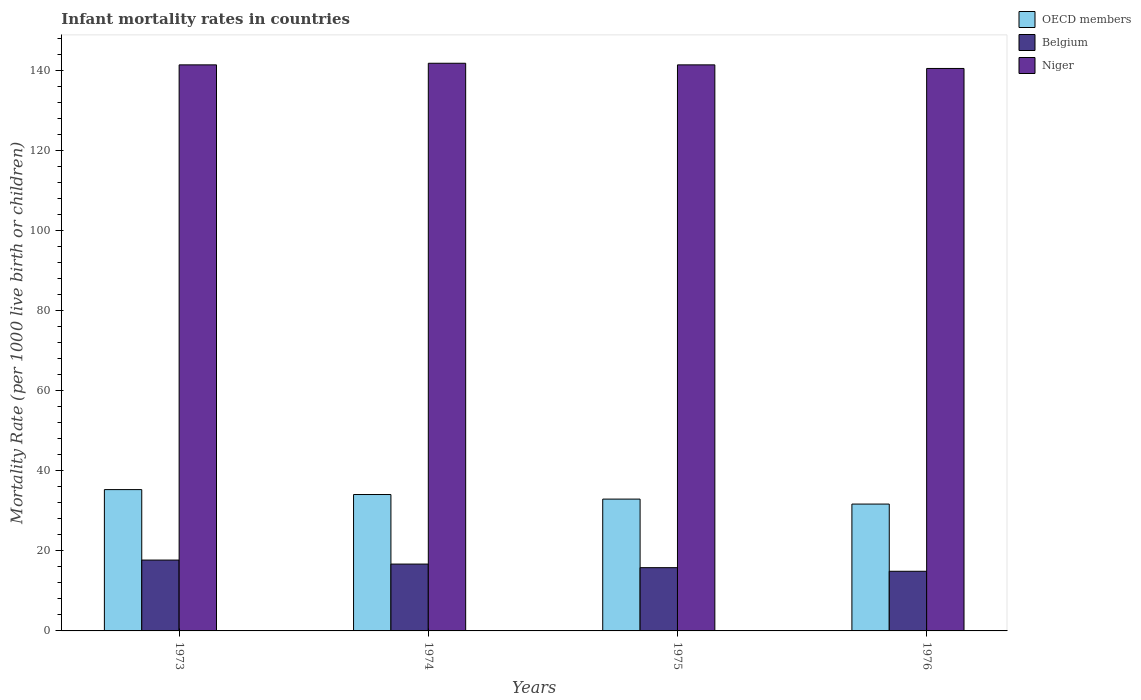Are the number of bars per tick equal to the number of legend labels?
Keep it short and to the point. Yes. Are the number of bars on each tick of the X-axis equal?
Offer a terse response. Yes. How many bars are there on the 4th tick from the right?
Offer a very short reply. 3. What is the label of the 3rd group of bars from the left?
Give a very brief answer. 1975. In how many cases, is the number of bars for a given year not equal to the number of legend labels?
Provide a short and direct response. 0. What is the infant mortality rate in Niger in 1974?
Give a very brief answer. 141.8. Across all years, what is the maximum infant mortality rate in OECD members?
Provide a succinct answer. 35.3. Across all years, what is the minimum infant mortality rate in Belgium?
Your answer should be compact. 14.9. In which year was the infant mortality rate in Niger maximum?
Offer a very short reply. 1974. In which year was the infant mortality rate in Belgium minimum?
Your response must be concise. 1976. What is the total infant mortality rate in Belgium in the graph?
Offer a very short reply. 65.1. What is the difference between the infant mortality rate in OECD members in 1973 and that in 1976?
Your answer should be compact. 3.62. What is the difference between the infant mortality rate in Niger in 1975 and the infant mortality rate in OECD members in 1974?
Provide a succinct answer. 107.33. What is the average infant mortality rate in OECD members per year?
Provide a short and direct response. 33.5. In the year 1973, what is the difference between the infant mortality rate in Belgium and infant mortality rate in Niger?
Give a very brief answer. -123.7. What is the ratio of the infant mortality rate in OECD members in 1973 to that in 1974?
Your answer should be very brief. 1.04. Is the difference between the infant mortality rate in Belgium in 1973 and 1975 greater than the difference between the infant mortality rate in Niger in 1973 and 1975?
Give a very brief answer. Yes. What is the difference between the highest and the second highest infant mortality rate in Niger?
Your answer should be compact. 0.4. What is the difference between the highest and the lowest infant mortality rate in Niger?
Give a very brief answer. 1.3. In how many years, is the infant mortality rate in Niger greater than the average infant mortality rate in Niger taken over all years?
Ensure brevity in your answer.  3. What does the 3rd bar from the left in 1976 represents?
Make the answer very short. Niger. Is it the case that in every year, the sum of the infant mortality rate in Belgium and infant mortality rate in Niger is greater than the infant mortality rate in OECD members?
Offer a very short reply. Yes. Are all the bars in the graph horizontal?
Your answer should be compact. No. What is the difference between two consecutive major ticks on the Y-axis?
Your answer should be compact. 20. Are the values on the major ticks of Y-axis written in scientific E-notation?
Ensure brevity in your answer.  No. Where does the legend appear in the graph?
Your answer should be very brief. Top right. How many legend labels are there?
Keep it short and to the point. 3. How are the legend labels stacked?
Offer a very short reply. Vertical. What is the title of the graph?
Keep it short and to the point. Infant mortality rates in countries. Does "French Polynesia" appear as one of the legend labels in the graph?
Make the answer very short. No. What is the label or title of the Y-axis?
Provide a succinct answer. Mortality Rate (per 1000 live birth or children). What is the Mortality Rate (per 1000 live birth or children) in OECD members in 1973?
Provide a succinct answer. 35.3. What is the Mortality Rate (per 1000 live birth or children) in Niger in 1973?
Your answer should be compact. 141.4. What is the Mortality Rate (per 1000 live birth or children) in OECD members in 1974?
Offer a very short reply. 34.07. What is the Mortality Rate (per 1000 live birth or children) in Niger in 1974?
Your answer should be compact. 141.8. What is the Mortality Rate (per 1000 live birth or children) of OECD members in 1975?
Provide a succinct answer. 32.93. What is the Mortality Rate (per 1000 live birth or children) of Niger in 1975?
Give a very brief answer. 141.4. What is the Mortality Rate (per 1000 live birth or children) of OECD members in 1976?
Provide a succinct answer. 31.69. What is the Mortality Rate (per 1000 live birth or children) in Belgium in 1976?
Make the answer very short. 14.9. What is the Mortality Rate (per 1000 live birth or children) of Niger in 1976?
Your answer should be compact. 140.5. Across all years, what is the maximum Mortality Rate (per 1000 live birth or children) of OECD members?
Your answer should be very brief. 35.3. Across all years, what is the maximum Mortality Rate (per 1000 live birth or children) of Niger?
Offer a terse response. 141.8. Across all years, what is the minimum Mortality Rate (per 1000 live birth or children) in OECD members?
Ensure brevity in your answer.  31.69. Across all years, what is the minimum Mortality Rate (per 1000 live birth or children) of Niger?
Provide a succinct answer. 140.5. What is the total Mortality Rate (per 1000 live birth or children) of OECD members in the graph?
Provide a succinct answer. 133.98. What is the total Mortality Rate (per 1000 live birth or children) in Belgium in the graph?
Offer a very short reply. 65.1. What is the total Mortality Rate (per 1000 live birth or children) of Niger in the graph?
Offer a terse response. 565.1. What is the difference between the Mortality Rate (per 1000 live birth or children) in OECD members in 1973 and that in 1974?
Make the answer very short. 1.23. What is the difference between the Mortality Rate (per 1000 live birth or children) of Belgium in 1973 and that in 1974?
Keep it short and to the point. 1. What is the difference between the Mortality Rate (per 1000 live birth or children) of Niger in 1973 and that in 1974?
Your answer should be compact. -0.4. What is the difference between the Mortality Rate (per 1000 live birth or children) in OECD members in 1973 and that in 1975?
Keep it short and to the point. 2.37. What is the difference between the Mortality Rate (per 1000 live birth or children) of Belgium in 1973 and that in 1975?
Keep it short and to the point. 1.9. What is the difference between the Mortality Rate (per 1000 live birth or children) of OECD members in 1973 and that in 1976?
Offer a terse response. 3.62. What is the difference between the Mortality Rate (per 1000 live birth or children) in Niger in 1973 and that in 1976?
Offer a terse response. 0.9. What is the difference between the Mortality Rate (per 1000 live birth or children) of OECD members in 1974 and that in 1975?
Provide a succinct answer. 1.14. What is the difference between the Mortality Rate (per 1000 live birth or children) in Niger in 1974 and that in 1975?
Provide a short and direct response. 0.4. What is the difference between the Mortality Rate (per 1000 live birth or children) of OECD members in 1974 and that in 1976?
Offer a terse response. 2.38. What is the difference between the Mortality Rate (per 1000 live birth or children) of Belgium in 1974 and that in 1976?
Your response must be concise. 1.8. What is the difference between the Mortality Rate (per 1000 live birth or children) in Niger in 1974 and that in 1976?
Your response must be concise. 1.3. What is the difference between the Mortality Rate (per 1000 live birth or children) of OECD members in 1975 and that in 1976?
Keep it short and to the point. 1.24. What is the difference between the Mortality Rate (per 1000 live birth or children) of Niger in 1975 and that in 1976?
Provide a succinct answer. 0.9. What is the difference between the Mortality Rate (per 1000 live birth or children) of OECD members in 1973 and the Mortality Rate (per 1000 live birth or children) of Belgium in 1974?
Your answer should be compact. 18.6. What is the difference between the Mortality Rate (per 1000 live birth or children) in OECD members in 1973 and the Mortality Rate (per 1000 live birth or children) in Niger in 1974?
Offer a terse response. -106.5. What is the difference between the Mortality Rate (per 1000 live birth or children) of Belgium in 1973 and the Mortality Rate (per 1000 live birth or children) of Niger in 1974?
Give a very brief answer. -124.1. What is the difference between the Mortality Rate (per 1000 live birth or children) in OECD members in 1973 and the Mortality Rate (per 1000 live birth or children) in Belgium in 1975?
Keep it short and to the point. 19.5. What is the difference between the Mortality Rate (per 1000 live birth or children) of OECD members in 1973 and the Mortality Rate (per 1000 live birth or children) of Niger in 1975?
Give a very brief answer. -106.1. What is the difference between the Mortality Rate (per 1000 live birth or children) of Belgium in 1973 and the Mortality Rate (per 1000 live birth or children) of Niger in 1975?
Offer a terse response. -123.7. What is the difference between the Mortality Rate (per 1000 live birth or children) in OECD members in 1973 and the Mortality Rate (per 1000 live birth or children) in Belgium in 1976?
Ensure brevity in your answer.  20.4. What is the difference between the Mortality Rate (per 1000 live birth or children) in OECD members in 1973 and the Mortality Rate (per 1000 live birth or children) in Niger in 1976?
Your answer should be very brief. -105.2. What is the difference between the Mortality Rate (per 1000 live birth or children) of Belgium in 1973 and the Mortality Rate (per 1000 live birth or children) of Niger in 1976?
Offer a terse response. -122.8. What is the difference between the Mortality Rate (per 1000 live birth or children) in OECD members in 1974 and the Mortality Rate (per 1000 live birth or children) in Belgium in 1975?
Offer a very short reply. 18.27. What is the difference between the Mortality Rate (per 1000 live birth or children) of OECD members in 1974 and the Mortality Rate (per 1000 live birth or children) of Niger in 1975?
Your answer should be very brief. -107.33. What is the difference between the Mortality Rate (per 1000 live birth or children) of Belgium in 1974 and the Mortality Rate (per 1000 live birth or children) of Niger in 1975?
Offer a terse response. -124.7. What is the difference between the Mortality Rate (per 1000 live birth or children) in OECD members in 1974 and the Mortality Rate (per 1000 live birth or children) in Belgium in 1976?
Keep it short and to the point. 19.17. What is the difference between the Mortality Rate (per 1000 live birth or children) of OECD members in 1974 and the Mortality Rate (per 1000 live birth or children) of Niger in 1976?
Ensure brevity in your answer.  -106.43. What is the difference between the Mortality Rate (per 1000 live birth or children) in Belgium in 1974 and the Mortality Rate (per 1000 live birth or children) in Niger in 1976?
Your response must be concise. -123.8. What is the difference between the Mortality Rate (per 1000 live birth or children) in OECD members in 1975 and the Mortality Rate (per 1000 live birth or children) in Belgium in 1976?
Ensure brevity in your answer.  18.03. What is the difference between the Mortality Rate (per 1000 live birth or children) in OECD members in 1975 and the Mortality Rate (per 1000 live birth or children) in Niger in 1976?
Your answer should be compact. -107.57. What is the difference between the Mortality Rate (per 1000 live birth or children) in Belgium in 1975 and the Mortality Rate (per 1000 live birth or children) in Niger in 1976?
Provide a succinct answer. -124.7. What is the average Mortality Rate (per 1000 live birth or children) in OECD members per year?
Offer a terse response. 33.5. What is the average Mortality Rate (per 1000 live birth or children) in Belgium per year?
Give a very brief answer. 16.27. What is the average Mortality Rate (per 1000 live birth or children) in Niger per year?
Keep it short and to the point. 141.28. In the year 1973, what is the difference between the Mortality Rate (per 1000 live birth or children) of OECD members and Mortality Rate (per 1000 live birth or children) of Belgium?
Provide a short and direct response. 17.6. In the year 1973, what is the difference between the Mortality Rate (per 1000 live birth or children) in OECD members and Mortality Rate (per 1000 live birth or children) in Niger?
Make the answer very short. -106.1. In the year 1973, what is the difference between the Mortality Rate (per 1000 live birth or children) of Belgium and Mortality Rate (per 1000 live birth or children) of Niger?
Give a very brief answer. -123.7. In the year 1974, what is the difference between the Mortality Rate (per 1000 live birth or children) in OECD members and Mortality Rate (per 1000 live birth or children) in Belgium?
Make the answer very short. 17.37. In the year 1974, what is the difference between the Mortality Rate (per 1000 live birth or children) in OECD members and Mortality Rate (per 1000 live birth or children) in Niger?
Keep it short and to the point. -107.73. In the year 1974, what is the difference between the Mortality Rate (per 1000 live birth or children) in Belgium and Mortality Rate (per 1000 live birth or children) in Niger?
Offer a terse response. -125.1. In the year 1975, what is the difference between the Mortality Rate (per 1000 live birth or children) in OECD members and Mortality Rate (per 1000 live birth or children) in Belgium?
Provide a short and direct response. 17.13. In the year 1975, what is the difference between the Mortality Rate (per 1000 live birth or children) in OECD members and Mortality Rate (per 1000 live birth or children) in Niger?
Offer a terse response. -108.47. In the year 1975, what is the difference between the Mortality Rate (per 1000 live birth or children) of Belgium and Mortality Rate (per 1000 live birth or children) of Niger?
Your response must be concise. -125.6. In the year 1976, what is the difference between the Mortality Rate (per 1000 live birth or children) of OECD members and Mortality Rate (per 1000 live birth or children) of Belgium?
Provide a short and direct response. 16.79. In the year 1976, what is the difference between the Mortality Rate (per 1000 live birth or children) in OECD members and Mortality Rate (per 1000 live birth or children) in Niger?
Make the answer very short. -108.81. In the year 1976, what is the difference between the Mortality Rate (per 1000 live birth or children) of Belgium and Mortality Rate (per 1000 live birth or children) of Niger?
Make the answer very short. -125.6. What is the ratio of the Mortality Rate (per 1000 live birth or children) of OECD members in 1973 to that in 1974?
Ensure brevity in your answer.  1.04. What is the ratio of the Mortality Rate (per 1000 live birth or children) of Belgium in 1973 to that in 1974?
Your answer should be compact. 1.06. What is the ratio of the Mortality Rate (per 1000 live birth or children) of OECD members in 1973 to that in 1975?
Provide a short and direct response. 1.07. What is the ratio of the Mortality Rate (per 1000 live birth or children) in Belgium in 1973 to that in 1975?
Make the answer very short. 1.12. What is the ratio of the Mortality Rate (per 1000 live birth or children) in OECD members in 1973 to that in 1976?
Provide a short and direct response. 1.11. What is the ratio of the Mortality Rate (per 1000 live birth or children) of Belgium in 1973 to that in 1976?
Your response must be concise. 1.19. What is the ratio of the Mortality Rate (per 1000 live birth or children) of Niger in 1973 to that in 1976?
Your response must be concise. 1.01. What is the ratio of the Mortality Rate (per 1000 live birth or children) in OECD members in 1974 to that in 1975?
Provide a short and direct response. 1.03. What is the ratio of the Mortality Rate (per 1000 live birth or children) in Belgium in 1974 to that in 1975?
Provide a short and direct response. 1.06. What is the ratio of the Mortality Rate (per 1000 live birth or children) in Niger in 1974 to that in 1975?
Offer a very short reply. 1. What is the ratio of the Mortality Rate (per 1000 live birth or children) of OECD members in 1974 to that in 1976?
Give a very brief answer. 1.08. What is the ratio of the Mortality Rate (per 1000 live birth or children) of Belgium in 1974 to that in 1976?
Give a very brief answer. 1.12. What is the ratio of the Mortality Rate (per 1000 live birth or children) in Niger in 1974 to that in 1976?
Provide a short and direct response. 1.01. What is the ratio of the Mortality Rate (per 1000 live birth or children) in OECD members in 1975 to that in 1976?
Give a very brief answer. 1.04. What is the ratio of the Mortality Rate (per 1000 live birth or children) in Belgium in 1975 to that in 1976?
Your answer should be very brief. 1.06. What is the ratio of the Mortality Rate (per 1000 live birth or children) in Niger in 1975 to that in 1976?
Your answer should be very brief. 1.01. What is the difference between the highest and the second highest Mortality Rate (per 1000 live birth or children) of OECD members?
Your answer should be very brief. 1.23. What is the difference between the highest and the second highest Mortality Rate (per 1000 live birth or children) of Niger?
Offer a very short reply. 0.4. What is the difference between the highest and the lowest Mortality Rate (per 1000 live birth or children) of OECD members?
Provide a short and direct response. 3.62. 